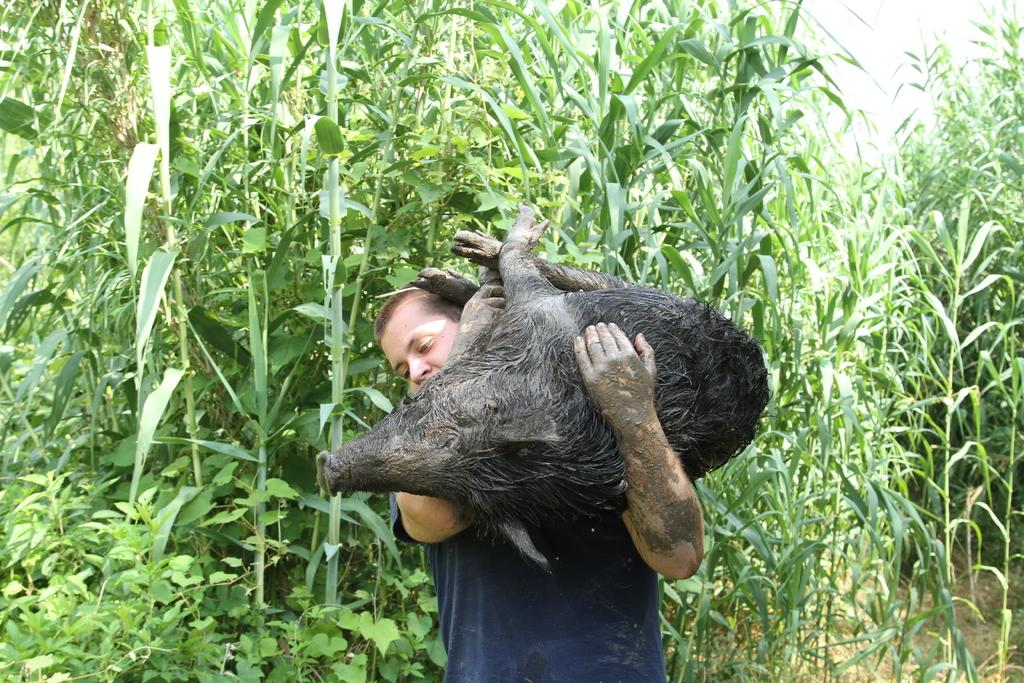Who or what is the main subject in the image? There is a person in the image. What is the person doing in the image? The person is carrying a pig. What can be seen in the background of the image? There are trees in the background of the image. What type of fire can be seen in the image? There is no fire present in the image; it features a person carrying a pig with trees in the background. 